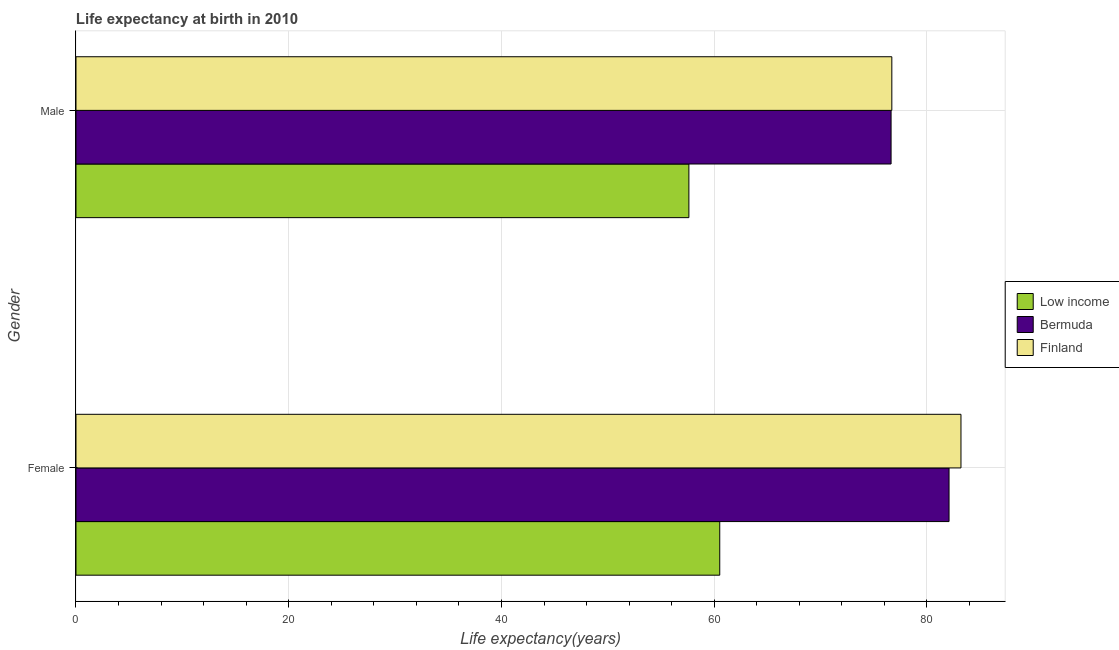How many groups of bars are there?
Offer a terse response. 2. Are the number of bars per tick equal to the number of legend labels?
Keep it short and to the point. Yes. Are the number of bars on each tick of the Y-axis equal?
Your answer should be very brief. Yes. How many bars are there on the 1st tick from the bottom?
Make the answer very short. 3. What is the life expectancy(male) in Finland?
Give a very brief answer. 76.7. Across all countries, what is the maximum life expectancy(male)?
Offer a terse response. 76.7. Across all countries, what is the minimum life expectancy(female)?
Ensure brevity in your answer.  60.52. In which country was the life expectancy(male) minimum?
Your answer should be compact. Low income. What is the total life expectancy(male) in the graph?
Keep it short and to the point. 210.95. What is the difference between the life expectancy(female) in Finland and that in Low income?
Offer a very short reply. 22.68. What is the difference between the life expectancy(male) in Finland and the life expectancy(female) in Low income?
Your response must be concise. 16.18. What is the average life expectancy(female) per country?
Offer a very short reply. 75.27. What is the difference between the life expectancy(male) and life expectancy(female) in Bermuda?
Offer a terse response. -5.45. What is the ratio of the life expectancy(female) in Bermuda to that in Low income?
Provide a short and direct response. 1.36. What does the 2nd bar from the bottom in Male represents?
Offer a terse response. Bermuda. How many bars are there?
Provide a succinct answer. 6. Are all the bars in the graph horizontal?
Your answer should be very brief. Yes. How many countries are there in the graph?
Provide a succinct answer. 3. Does the graph contain grids?
Your answer should be compact. Yes. Where does the legend appear in the graph?
Your answer should be compact. Center right. How many legend labels are there?
Your answer should be very brief. 3. What is the title of the graph?
Keep it short and to the point. Life expectancy at birth in 2010. Does "Hong Kong" appear as one of the legend labels in the graph?
Keep it short and to the point. No. What is the label or title of the X-axis?
Your response must be concise. Life expectancy(years). What is the label or title of the Y-axis?
Offer a terse response. Gender. What is the Life expectancy(years) of Low income in Female?
Keep it short and to the point. 60.52. What is the Life expectancy(years) of Bermuda in Female?
Keep it short and to the point. 82.08. What is the Life expectancy(years) of Finland in Female?
Make the answer very short. 83.2. What is the Life expectancy(years) of Low income in Male?
Offer a very short reply. 57.62. What is the Life expectancy(years) in Bermuda in Male?
Your response must be concise. 76.63. What is the Life expectancy(years) of Finland in Male?
Keep it short and to the point. 76.7. Across all Gender, what is the maximum Life expectancy(years) of Low income?
Ensure brevity in your answer.  60.52. Across all Gender, what is the maximum Life expectancy(years) of Bermuda?
Give a very brief answer. 82.08. Across all Gender, what is the maximum Life expectancy(years) in Finland?
Provide a short and direct response. 83.2. Across all Gender, what is the minimum Life expectancy(years) of Low income?
Your response must be concise. 57.62. Across all Gender, what is the minimum Life expectancy(years) of Bermuda?
Your answer should be compact. 76.63. Across all Gender, what is the minimum Life expectancy(years) of Finland?
Keep it short and to the point. 76.7. What is the total Life expectancy(years) of Low income in the graph?
Provide a short and direct response. 118.14. What is the total Life expectancy(years) in Bermuda in the graph?
Offer a very short reply. 158.71. What is the total Life expectancy(years) of Finland in the graph?
Keep it short and to the point. 159.9. What is the difference between the Life expectancy(years) in Low income in Female and that in Male?
Make the answer very short. 2.9. What is the difference between the Life expectancy(years) of Bermuda in Female and that in Male?
Provide a succinct answer. 5.45. What is the difference between the Life expectancy(years) in Finland in Female and that in Male?
Make the answer very short. 6.5. What is the difference between the Life expectancy(years) in Low income in Female and the Life expectancy(years) in Bermuda in Male?
Your answer should be compact. -16.11. What is the difference between the Life expectancy(years) of Low income in Female and the Life expectancy(years) of Finland in Male?
Your answer should be compact. -16.18. What is the difference between the Life expectancy(years) in Bermuda in Female and the Life expectancy(years) in Finland in Male?
Ensure brevity in your answer.  5.38. What is the average Life expectancy(years) in Low income per Gender?
Offer a very short reply. 59.07. What is the average Life expectancy(years) in Bermuda per Gender?
Provide a short and direct response. 79.36. What is the average Life expectancy(years) in Finland per Gender?
Give a very brief answer. 79.95. What is the difference between the Life expectancy(years) in Low income and Life expectancy(years) in Bermuda in Female?
Your answer should be compact. -21.56. What is the difference between the Life expectancy(years) of Low income and Life expectancy(years) of Finland in Female?
Offer a terse response. -22.68. What is the difference between the Life expectancy(years) in Bermuda and Life expectancy(years) in Finland in Female?
Your answer should be compact. -1.12. What is the difference between the Life expectancy(years) of Low income and Life expectancy(years) of Bermuda in Male?
Ensure brevity in your answer.  -19.01. What is the difference between the Life expectancy(years) in Low income and Life expectancy(years) in Finland in Male?
Offer a very short reply. -19.08. What is the difference between the Life expectancy(years) of Bermuda and Life expectancy(years) of Finland in Male?
Your response must be concise. -0.07. What is the ratio of the Life expectancy(years) in Low income in Female to that in Male?
Offer a terse response. 1.05. What is the ratio of the Life expectancy(years) in Bermuda in Female to that in Male?
Offer a very short reply. 1.07. What is the ratio of the Life expectancy(years) in Finland in Female to that in Male?
Your response must be concise. 1.08. What is the difference between the highest and the second highest Life expectancy(years) of Low income?
Keep it short and to the point. 2.9. What is the difference between the highest and the second highest Life expectancy(years) of Bermuda?
Offer a very short reply. 5.45. What is the difference between the highest and the lowest Life expectancy(years) of Low income?
Ensure brevity in your answer.  2.9. What is the difference between the highest and the lowest Life expectancy(years) in Bermuda?
Give a very brief answer. 5.45. 